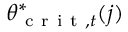Convert formula to latex. <formula><loc_0><loc_0><loc_500><loc_500>\theta _ { c r i t , t } ^ { * } ( j )</formula> 